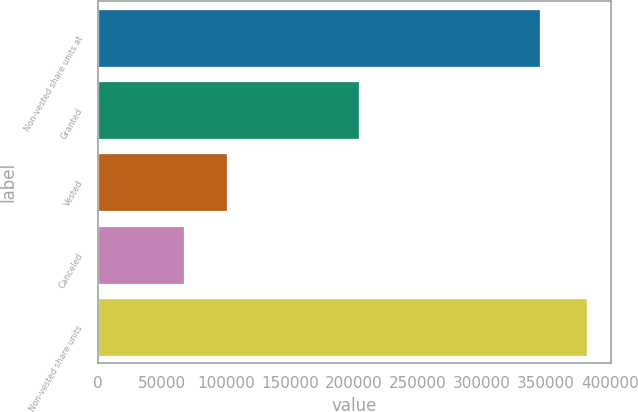<chart> <loc_0><loc_0><loc_500><loc_500><bar_chart><fcel>Non-vested share units at<fcel>Granted<fcel>Vested<fcel>Canceled<fcel>Non-vested share units<nl><fcel>345530<fcel>204154<fcel>100693<fcel>67524<fcel>381467<nl></chart> 